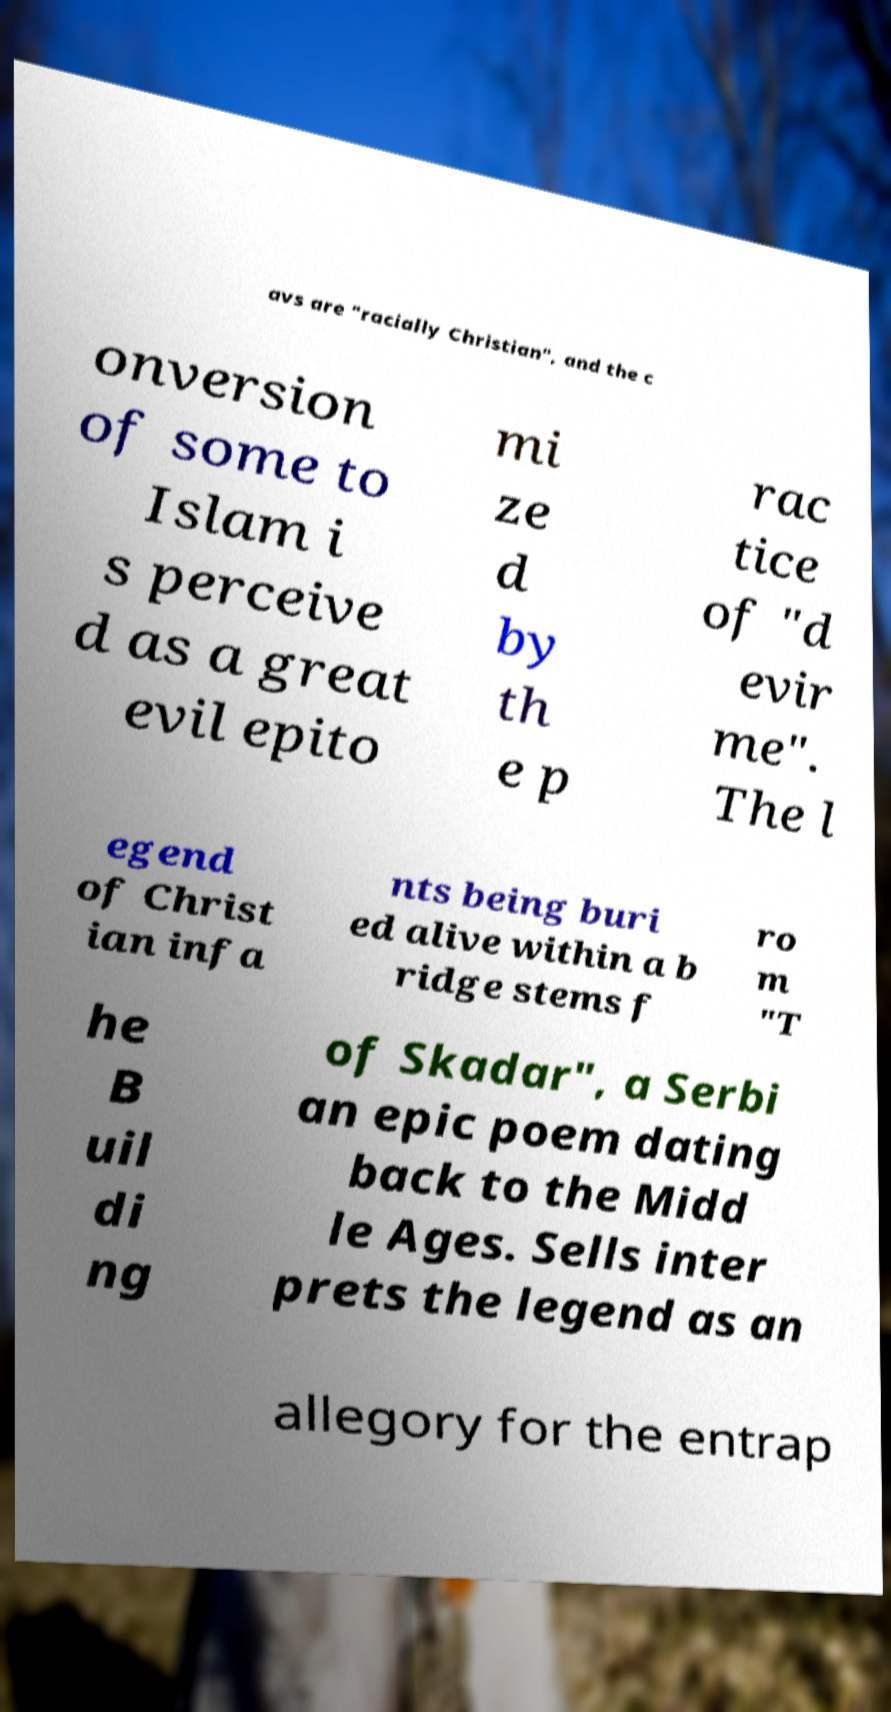Can you read and provide the text displayed in the image?This photo seems to have some interesting text. Can you extract and type it out for me? avs are "racially Christian", and the c onversion of some to Islam i s perceive d as a great evil epito mi ze d by th e p rac tice of "d evir me". The l egend of Christ ian infa nts being buri ed alive within a b ridge stems f ro m "T he B uil di ng of Skadar", a Serbi an epic poem dating back to the Midd le Ages. Sells inter prets the legend as an allegory for the entrap 